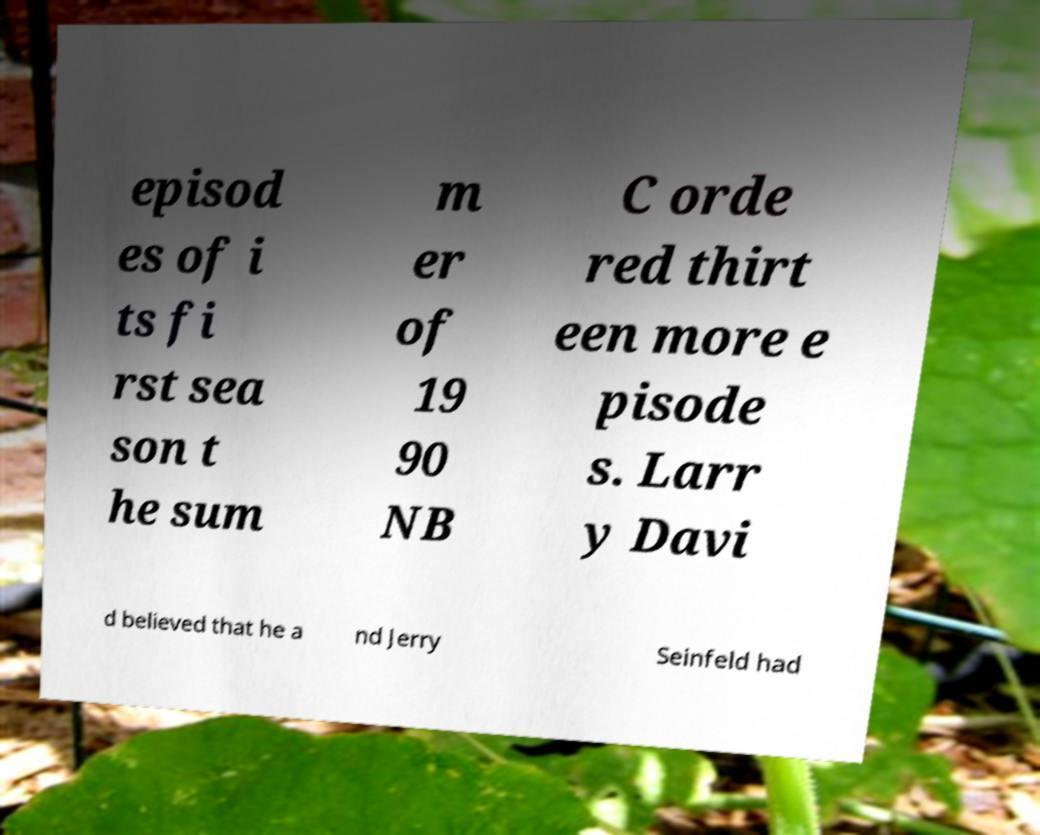Could you assist in decoding the text presented in this image and type it out clearly? episod es of i ts fi rst sea son t he sum m er of 19 90 NB C orde red thirt een more e pisode s. Larr y Davi d believed that he a nd Jerry Seinfeld had 